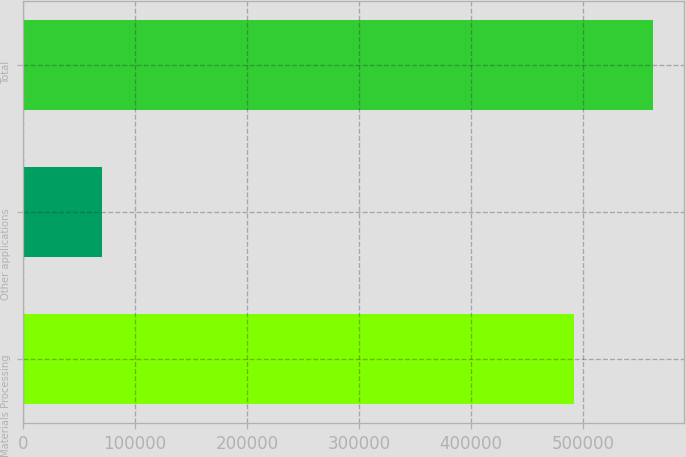Convert chart. <chart><loc_0><loc_0><loc_500><loc_500><bar_chart><fcel>Materials Processing<fcel>Other applications<fcel>Total<nl><fcel>492013<fcel>70515<fcel>562528<nl></chart> 